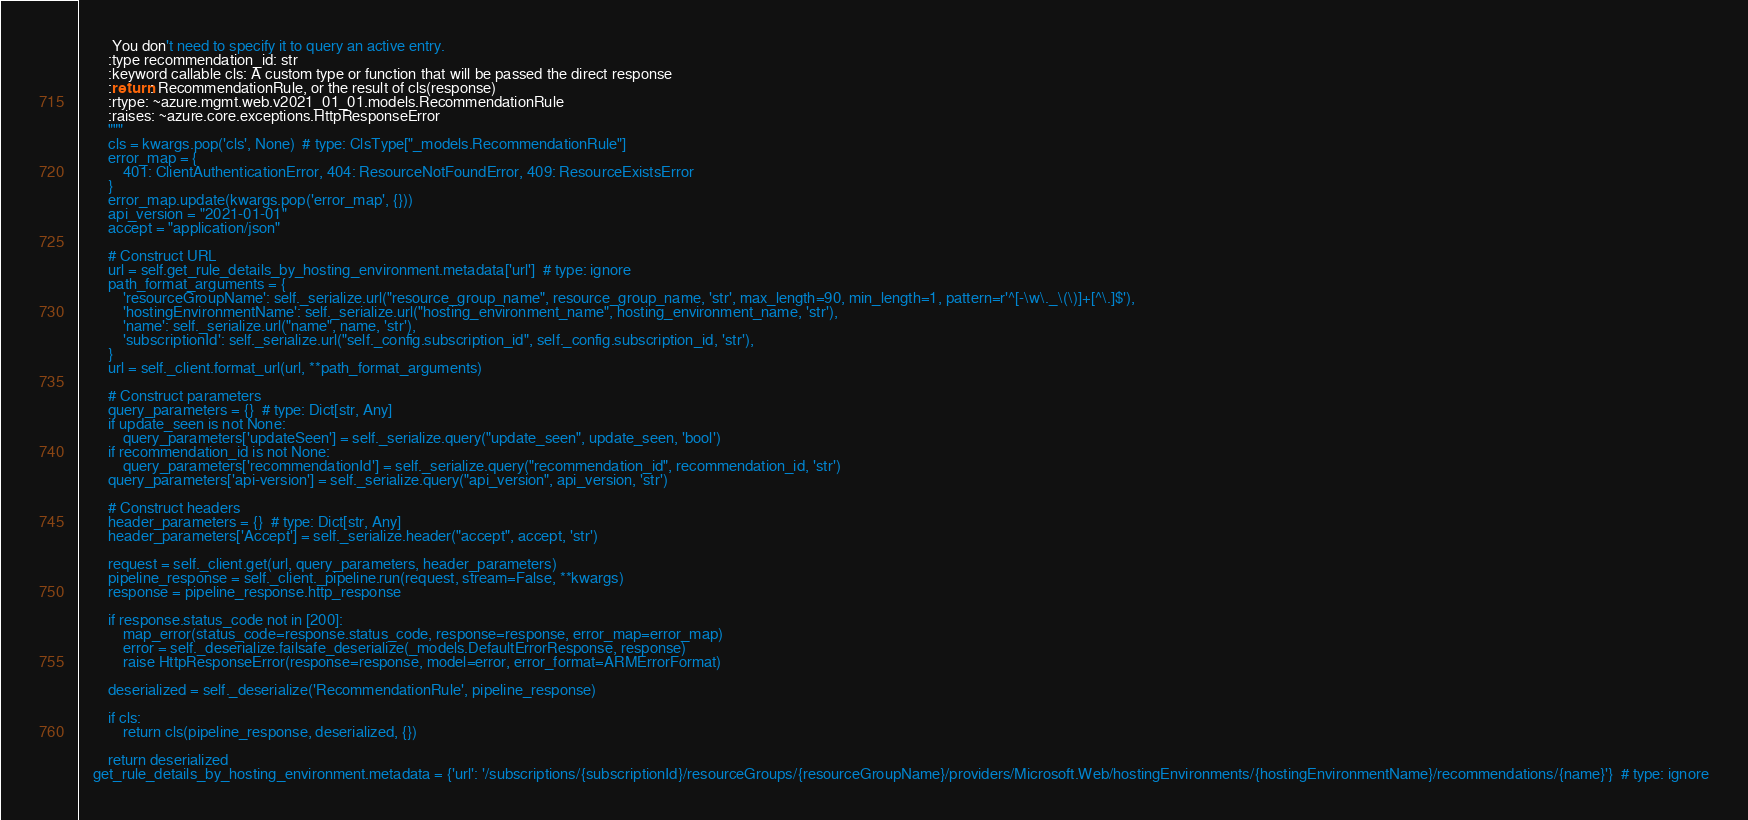<code> <loc_0><loc_0><loc_500><loc_500><_Python_>         You don't need to specify it to query an active entry.
        :type recommendation_id: str
        :keyword callable cls: A custom type or function that will be passed the direct response
        :return: RecommendationRule, or the result of cls(response)
        :rtype: ~azure.mgmt.web.v2021_01_01.models.RecommendationRule
        :raises: ~azure.core.exceptions.HttpResponseError
        """
        cls = kwargs.pop('cls', None)  # type: ClsType["_models.RecommendationRule"]
        error_map = {
            401: ClientAuthenticationError, 404: ResourceNotFoundError, 409: ResourceExistsError
        }
        error_map.update(kwargs.pop('error_map', {}))
        api_version = "2021-01-01"
        accept = "application/json"

        # Construct URL
        url = self.get_rule_details_by_hosting_environment.metadata['url']  # type: ignore
        path_format_arguments = {
            'resourceGroupName': self._serialize.url("resource_group_name", resource_group_name, 'str', max_length=90, min_length=1, pattern=r'^[-\w\._\(\)]+[^\.]$'),
            'hostingEnvironmentName': self._serialize.url("hosting_environment_name", hosting_environment_name, 'str'),
            'name': self._serialize.url("name", name, 'str'),
            'subscriptionId': self._serialize.url("self._config.subscription_id", self._config.subscription_id, 'str'),
        }
        url = self._client.format_url(url, **path_format_arguments)

        # Construct parameters
        query_parameters = {}  # type: Dict[str, Any]
        if update_seen is not None:
            query_parameters['updateSeen'] = self._serialize.query("update_seen", update_seen, 'bool')
        if recommendation_id is not None:
            query_parameters['recommendationId'] = self._serialize.query("recommendation_id", recommendation_id, 'str')
        query_parameters['api-version'] = self._serialize.query("api_version", api_version, 'str')

        # Construct headers
        header_parameters = {}  # type: Dict[str, Any]
        header_parameters['Accept'] = self._serialize.header("accept", accept, 'str')

        request = self._client.get(url, query_parameters, header_parameters)
        pipeline_response = self._client._pipeline.run(request, stream=False, **kwargs)
        response = pipeline_response.http_response

        if response.status_code not in [200]:
            map_error(status_code=response.status_code, response=response, error_map=error_map)
            error = self._deserialize.failsafe_deserialize(_models.DefaultErrorResponse, response)
            raise HttpResponseError(response=response, model=error, error_format=ARMErrorFormat)

        deserialized = self._deserialize('RecommendationRule', pipeline_response)

        if cls:
            return cls(pipeline_response, deserialized, {})

        return deserialized
    get_rule_details_by_hosting_environment.metadata = {'url': '/subscriptions/{subscriptionId}/resourceGroups/{resourceGroupName}/providers/Microsoft.Web/hostingEnvironments/{hostingEnvironmentName}/recommendations/{name}'}  # type: ignore
</code> 